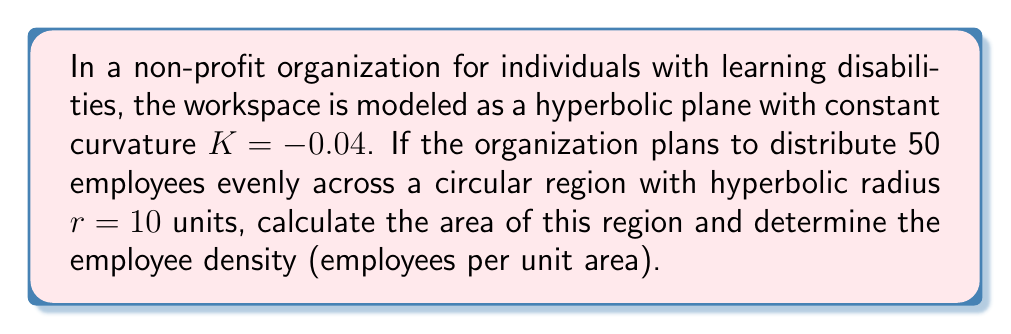Can you solve this math problem? 1. In hyperbolic geometry, the area of a circle with radius $r$ is given by the formula:
   $$A = \frac{4\pi}{|K|} \sinh^2(\frac{\sqrt{|K|}r}{2})$$
   where $K$ is the curvature and $r$ is the radius.

2. We are given $K = -0.04$ and $r = 10$. Let's substitute these values:
   $$A = \frac{4\pi}{|-0.04|} \sinh^2(\frac{\sqrt{|-0.04|}10}{2})$$

3. Simplify:
   $$A = 100\pi \sinh^2(0.1\sqrt{10})$$

4. Calculate the value inside sinh:
   $$0.1\sqrt{10} \approx 0.3162$$

5. Now calculate the area:
   $$A \approx 100\pi \sinh^2(0.3162) \approx 100\pi \cdot 0.1003 \approx 31.52$$

6. To find the employee density, divide the number of employees by the area:
   $$\text{Density} = \frac{50}{31.52} \approx 1.59 \text{ employees per unit area}$$
Answer: Area: $31.52$ square units; Density: $1.59$ employees per square unit 